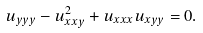<formula> <loc_0><loc_0><loc_500><loc_500>u _ { y y y } - u _ { x x y } ^ { 2 } + u _ { x x x } u _ { x y y } = 0 .</formula> 